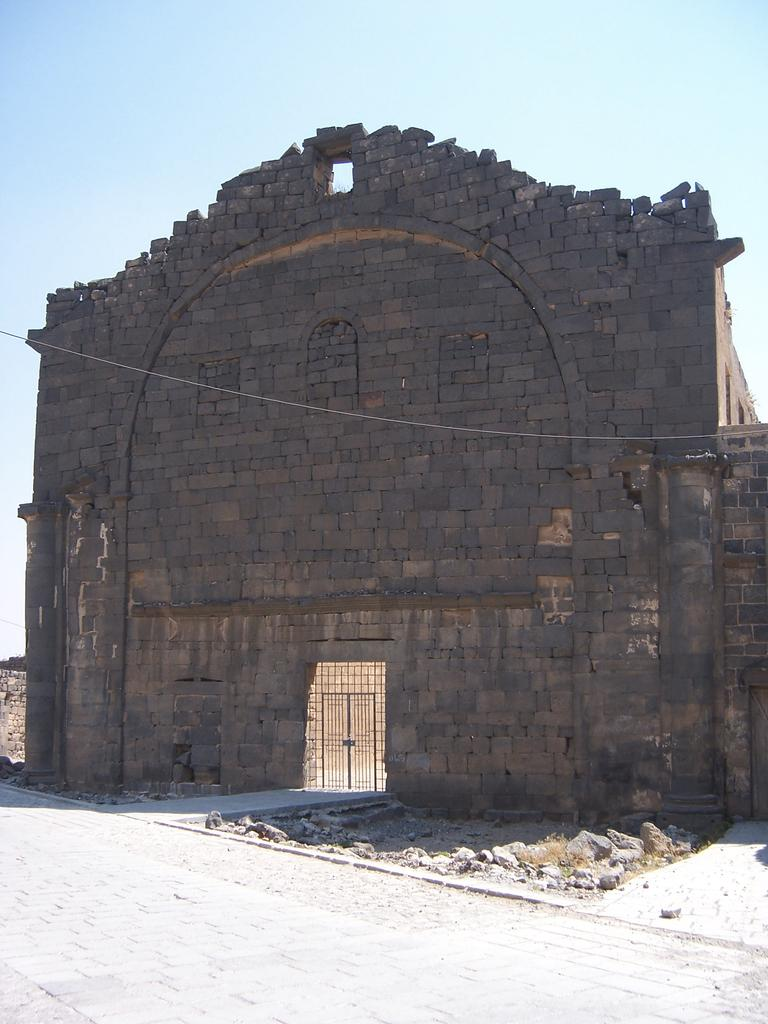What type of structure can be seen in the picture? There is a building in the picture. What can be seen in the background of the picture? The sky is visible in the background of the picture. How many friends are sitting on the haircut in the picture? There is no haircut or friends present in the image. 